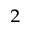Convert formula to latex. <formula><loc_0><loc_0><loc_500><loc_500>^ { 2 }</formula> 